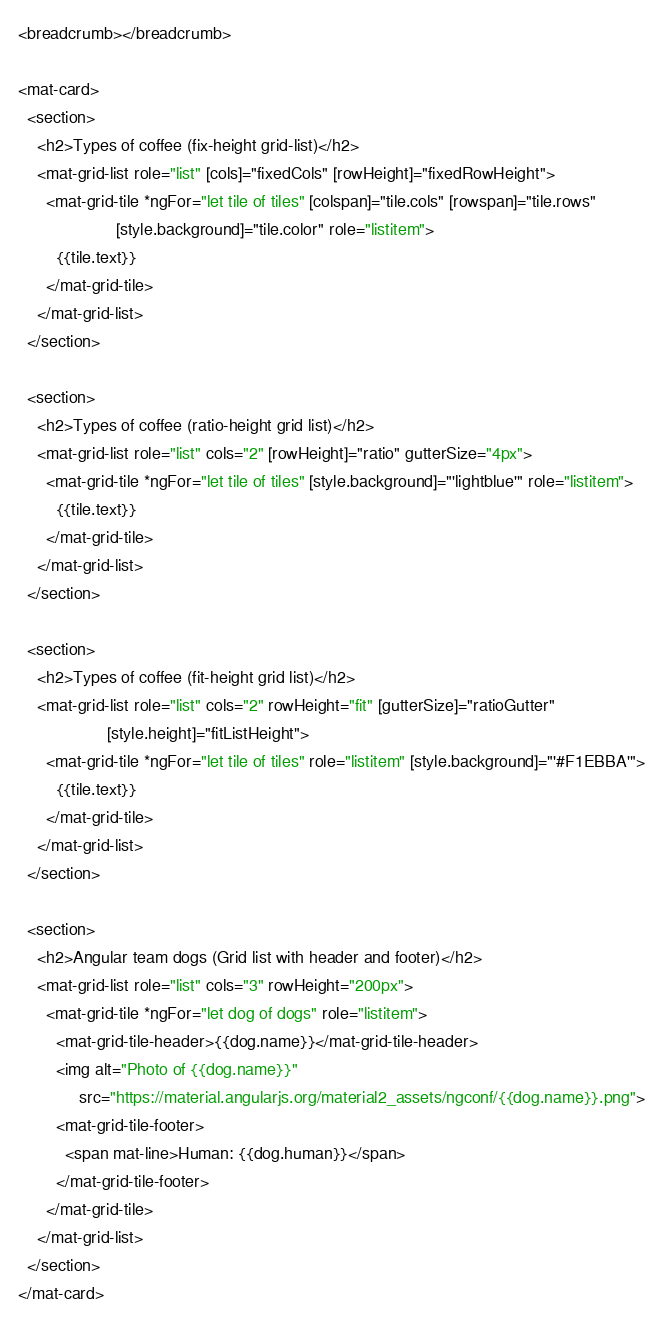Convert code to text. <code><loc_0><loc_0><loc_500><loc_500><_HTML_><breadcrumb></breadcrumb>

<mat-card>
  <section>
    <h2>Types of coffee (fix-height grid-list)</h2>
    <mat-grid-list role="list" [cols]="fixedCols" [rowHeight]="fixedRowHeight">
      <mat-grid-tile *ngFor="let tile of tiles" [colspan]="tile.cols" [rowspan]="tile.rows"
                     [style.background]="tile.color" role="listitem">
        {{tile.text}}
      </mat-grid-tile>
    </mat-grid-list>
  </section>

  <section>
    <h2>Types of coffee (ratio-height grid list)</h2>
    <mat-grid-list role="list" cols="2" [rowHeight]="ratio" gutterSize="4px">
      <mat-grid-tile *ngFor="let tile of tiles" [style.background]="'lightblue'" role="listitem">
        {{tile.text}}
      </mat-grid-tile>
    </mat-grid-list>
  </section>

  <section>
    <h2>Types of coffee (fit-height grid list)</h2>
    <mat-grid-list role="list" cols="2" rowHeight="fit" [gutterSize]="ratioGutter"
                   [style.height]="fitListHeight">
      <mat-grid-tile *ngFor="let tile of tiles" role="listitem" [style.background]="'#F1EBBA'">
        {{tile.text}}
      </mat-grid-tile>
    </mat-grid-list>
  </section>

  <section>
    <h2>Angular team dogs (Grid list with header and footer)</h2>
    <mat-grid-list role="list" cols="3" rowHeight="200px">
      <mat-grid-tile *ngFor="let dog of dogs" role="listitem">
        <mat-grid-tile-header>{{dog.name}}</mat-grid-tile-header>
        <img alt="Photo of {{dog.name}}"
             src="https://material.angularjs.org/material2_assets/ngconf/{{dog.name}}.png">
        <mat-grid-tile-footer>
          <span mat-line>Human: {{dog.human}}</span>
        </mat-grid-tile-footer>
      </mat-grid-tile>
    </mat-grid-list>
  </section>
</mat-card></code> 